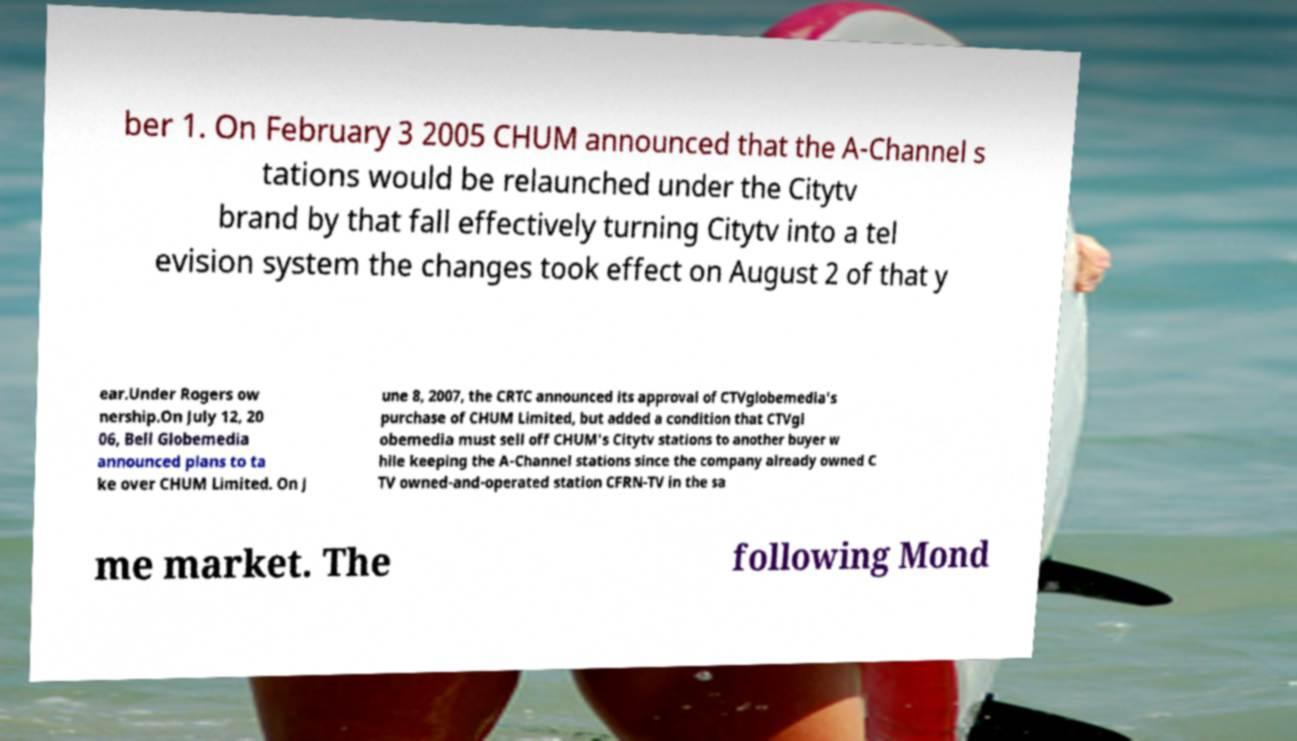Can you read and provide the text displayed in the image?This photo seems to have some interesting text. Can you extract and type it out for me? ber 1. On February 3 2005 CHUM announced that the A-Channel s tations would be relaunched under the Citytv brand by that fall effectively turning Citytv into a tel evision system the changes took effect on August 2 of that y ear.Under Rogers ow nership.On July 12, 20 06, Bell Globemedia announced plans to ta ke over CHUM Limited. On J une 8, 2007, the CRTC announced its approval of CTVglobemedia's purchase of CHUM Limited, but added a condition that CTVgl obemedia must sell off CHUM's Citytv stations to another buyer w hile keeping the A-Channel stations since the company already owned C TV owned-and-operated station CFRN-TV in the sa me market. The following Mond 